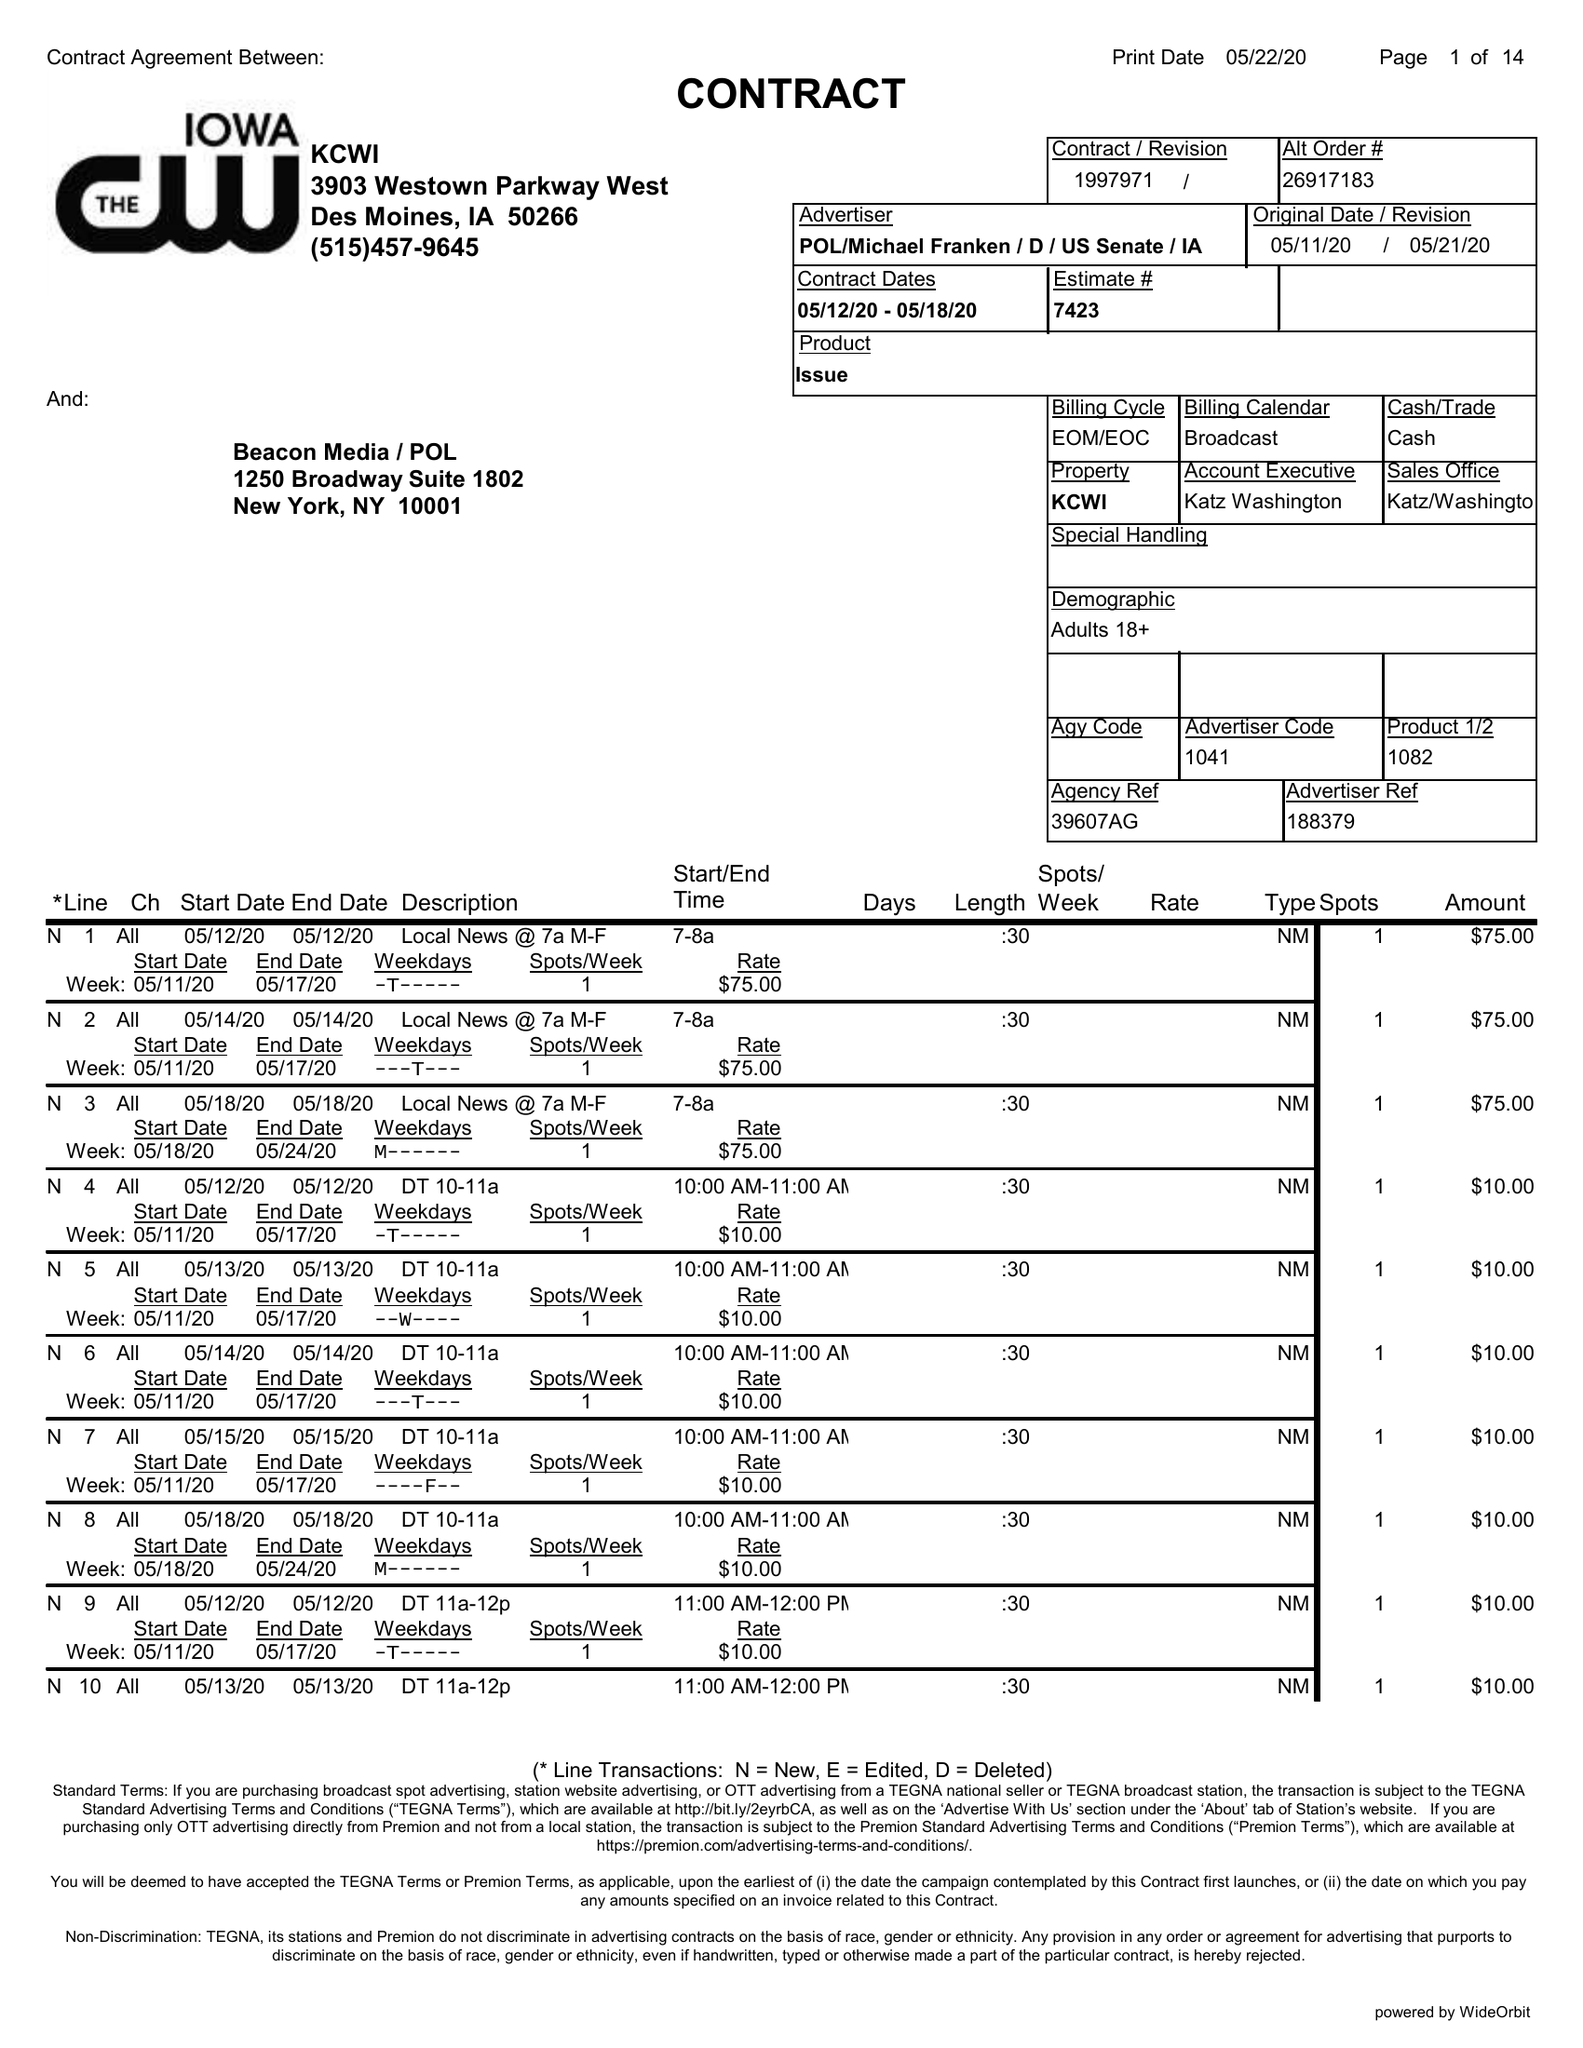What is the value for the flight_from?
Answer the question using a single word or phrase. 05/12/20 